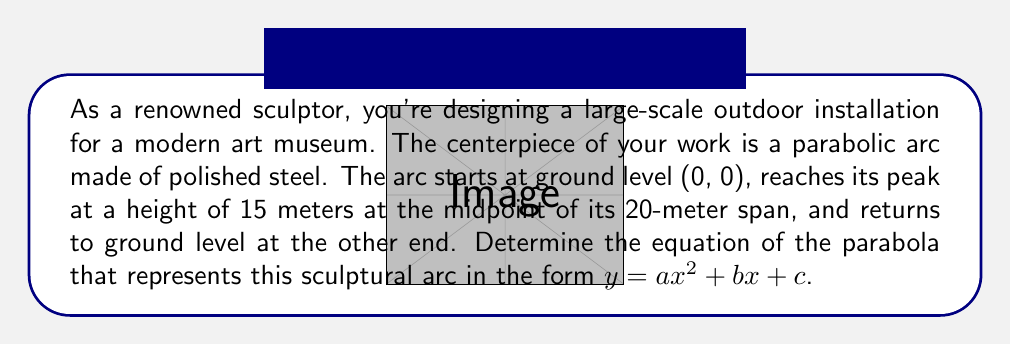Solve this math problem. Let's approach this step-by-step:

1) We know the parabola passes through three points:
   (0, 0), (10, 15), and (20, 0)

2) The general form of a parabola is $y = ax^2 + bx + c$

3) Using the first point (0, 0):
   $0 = a(0)^2 + b(0) + c$
   $c = 0$

4) Now we can use the other two points to create a system of equations:
   For (10, 15): $15 = 100a + 10b$
   For (20, 0): $0 = 400a + 20b$

5) Simplify the equations:
   $15 = 100a + 10b$ ... (Equation 1)
   $0 = 400a + 20b$ ... (Equation 2)

6) Multiply Equation 1 by 4 and Equation 2 by -1:
   $60 = 400a + 40b$ ... (Equation 3)
   $0 = -400a - 20b$ ... (Equation 4)

7) Add Equations 3 and 4:
   $60 = 20b$
   $b = 3$

8) Substitute $b = 3$ into Equation 1:
   $15 = 100a + 10(3)$
   $15 = 100a + 30$
   $-15 = 100a$
   $a = -0.15$

9) Therefore, the equation of the parabola is:
   $y = -0.15x^2 + 3x + 0$
   
   Which simplifies to:
   $y = -0.15x^2 + 3x$

We can verify this by checking our original points:
(0, 0): $y = -0.15(0)^2 + 3(0) = 0$
(10, 15): $y = -0.15(10)^2 + 3(10) = -15 + 30 = 15$
(20, 0): $y = -0.15(20)^2 + 3(20) = -60 + 60 = 0$
Answer: $y = -0.15x^2 + 3x$ 